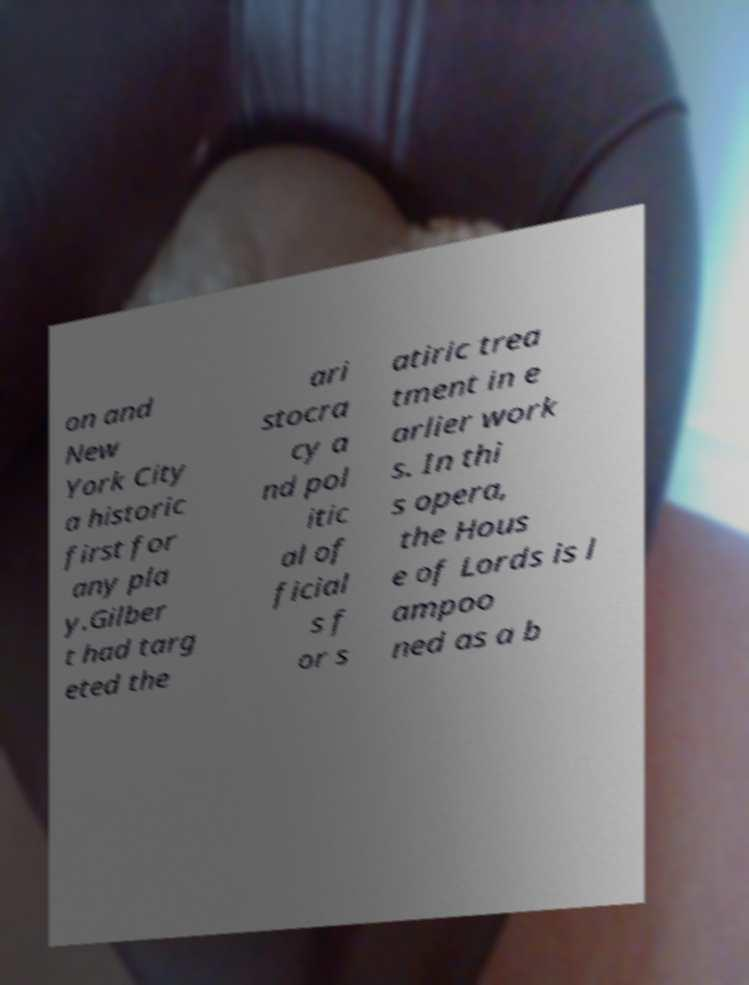Can you accurately transcribe the text from the provided image for me? on and New York City a historic first for any pla y.Gilber t had targ eted the ari stocra cy a nd pol itic al of ficial s f or s atiric trea tment in e arlier work s. In thi s opera, the Hous e of Lords is l ampoo ned as a b 